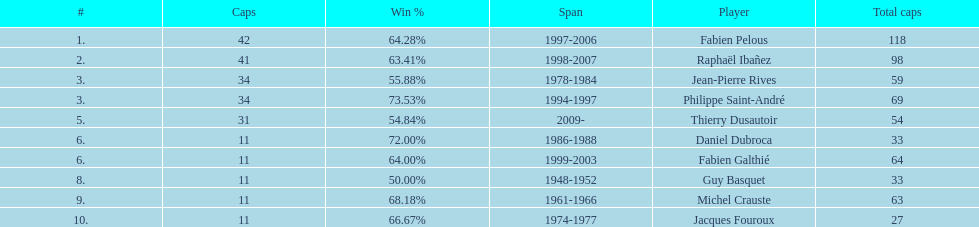Which captain served the least amount of time? Daniel Dubroca. 